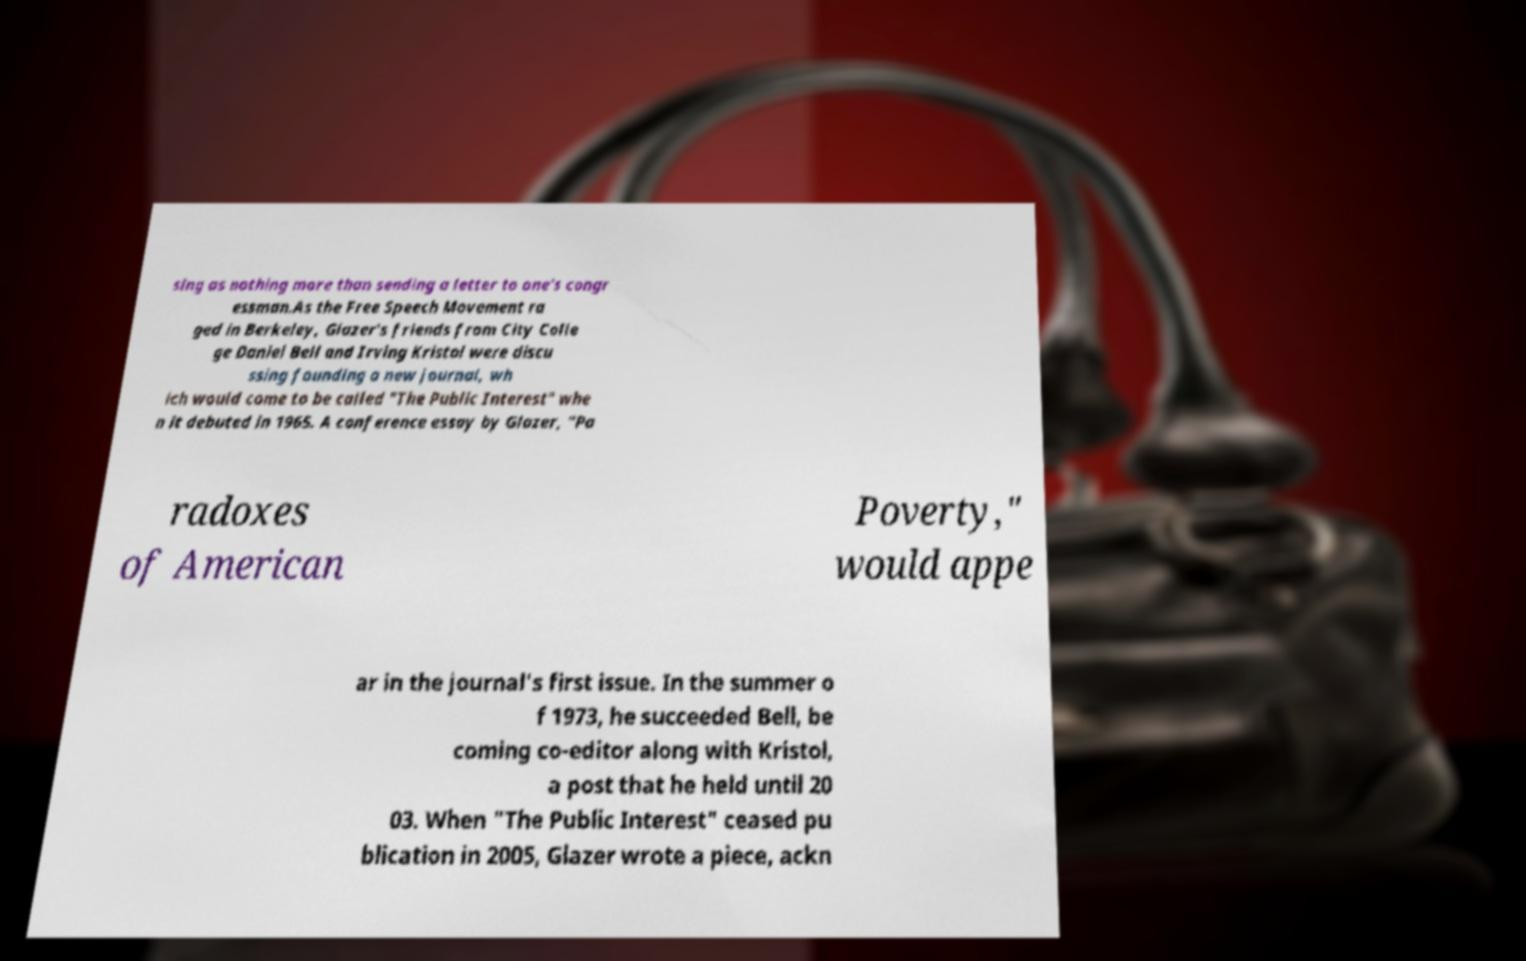For documentation purposes, I need the text within this image transcribed. Could you provide that? sing as nothing more than sending a letter to one's congr essman.As the Free Speech Movement ra ged in Berkeley, Glazer's friends from City Colle ge Daniel Bell and Irving Kristol were discu ssing founding a new journal, wh ich would come to be called "The Public Interest" whe n it debuted in 1965. A conference essay by Glazer, "Pa radoxes of American Poverty," would appe ar in the journal's first issue. In the summer o f 1973, he succeeded Bell, be coming co-editor along with Kristol, a post that he held until 20 03. When "The Public Interest" ceased pu blication in 2005, Glazer wrote a piece, ackn 